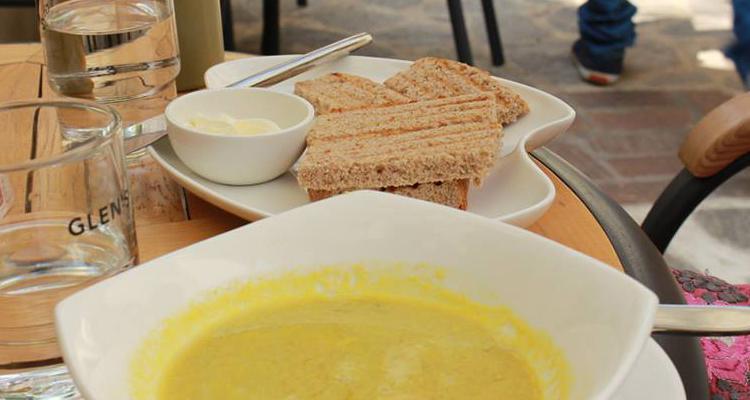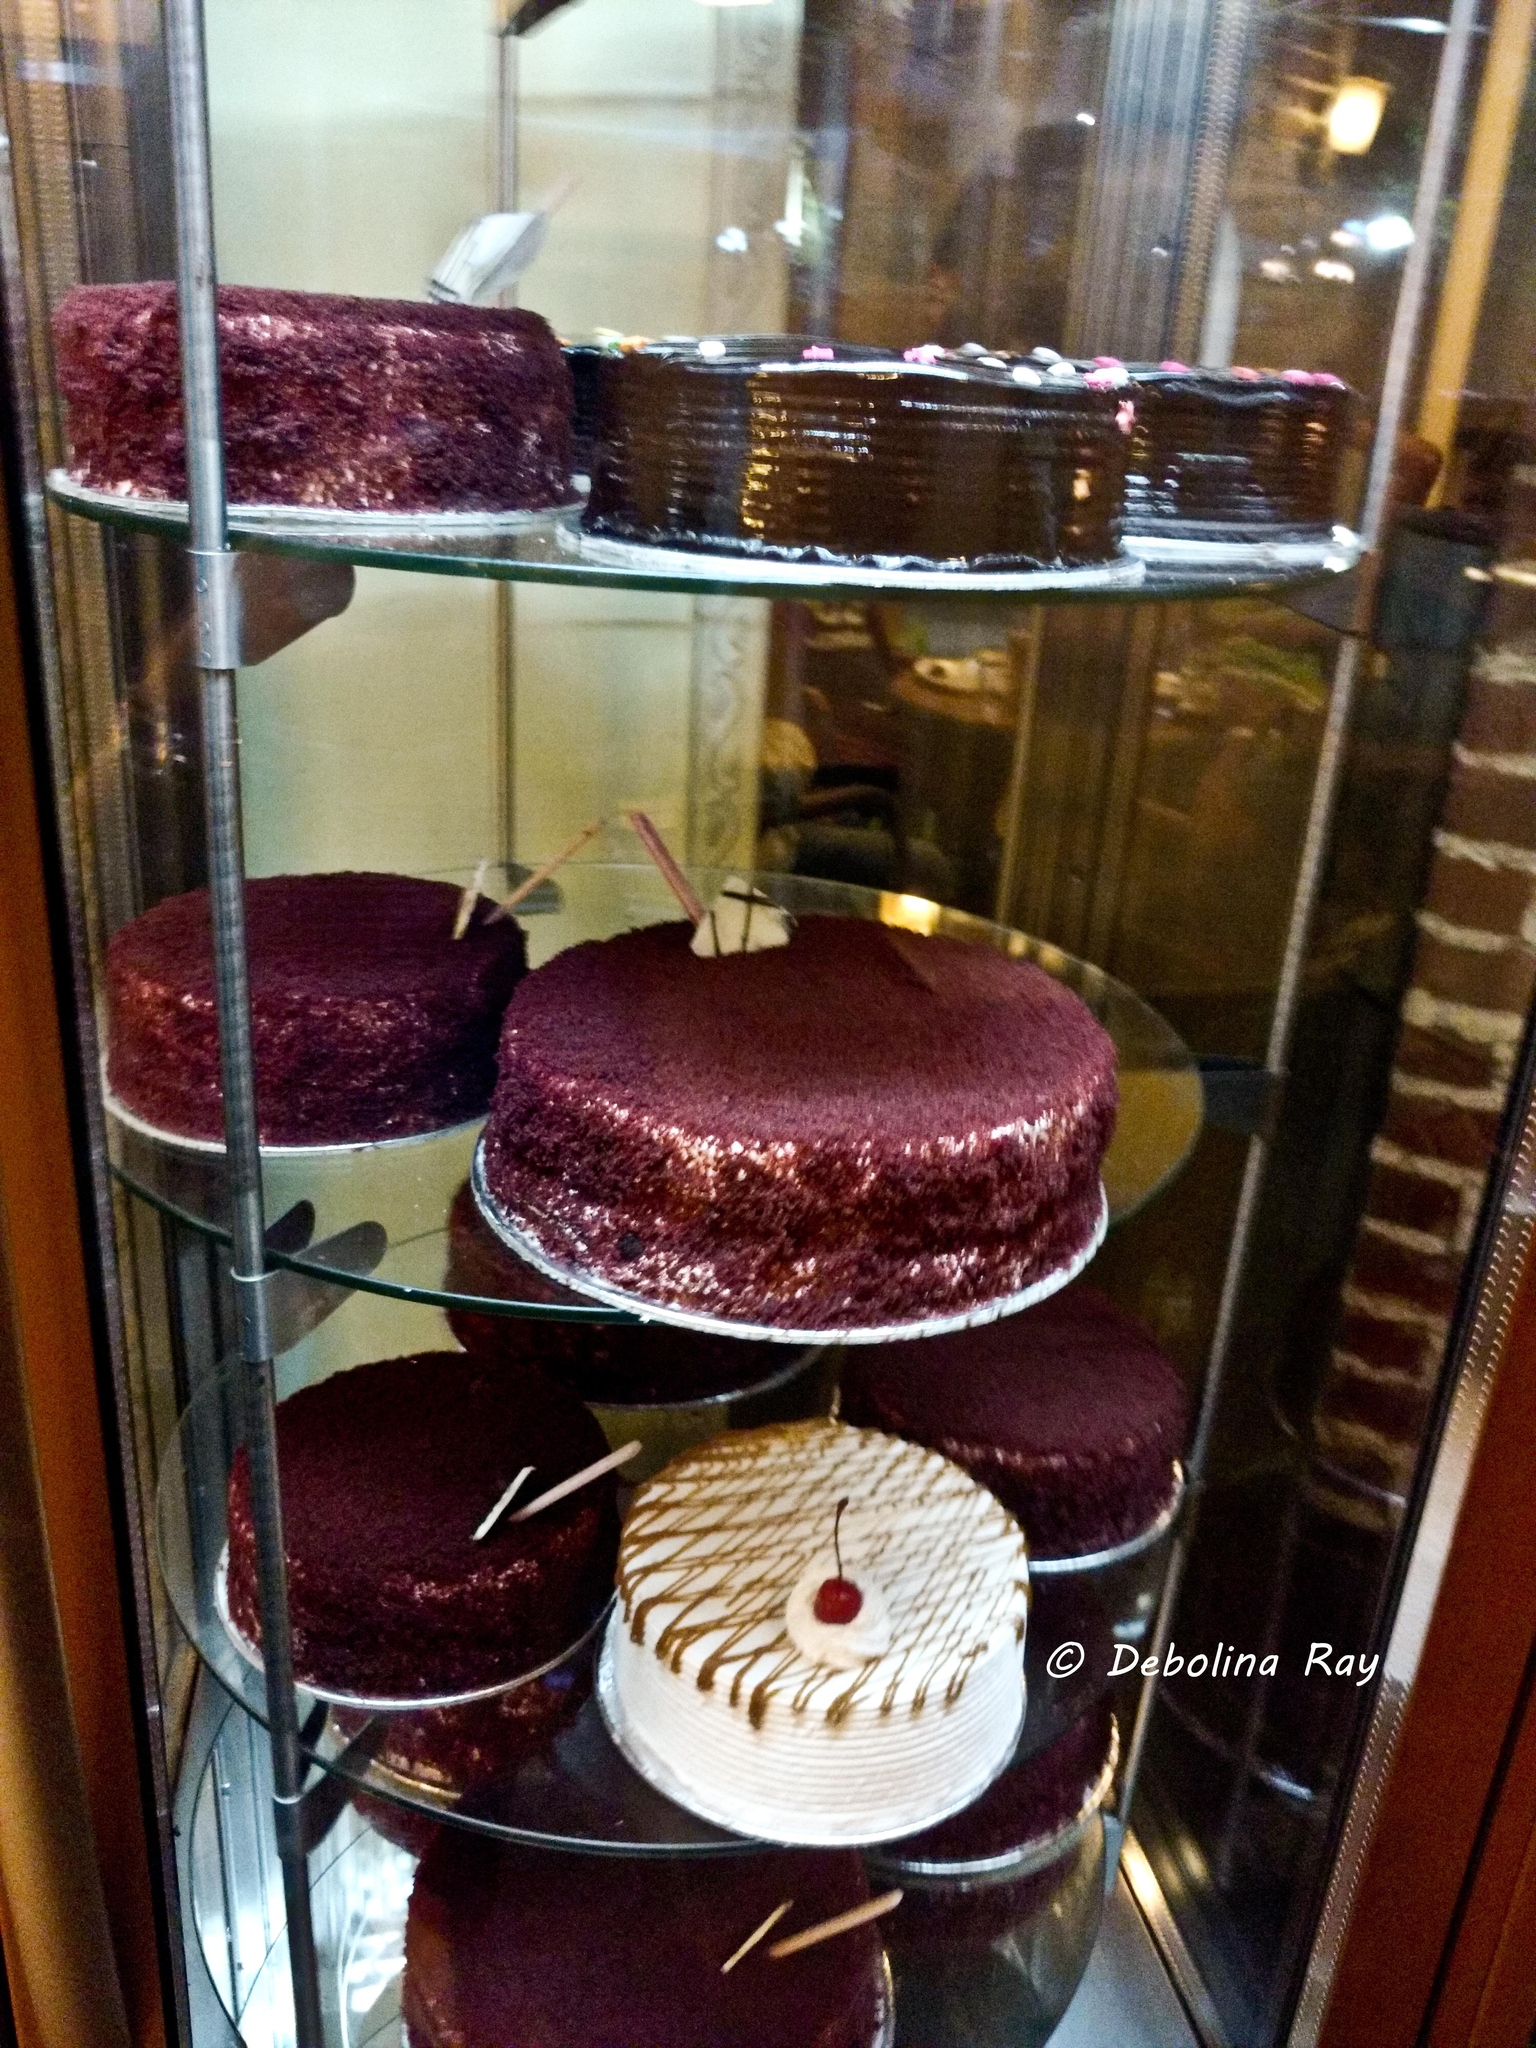The first image is the image on the left, the second image is the image on the right. Assess this claim about the two images: "The right image shows round frosted cake-type desserts displayed on round glass shelves in a tall glass-fronted case.". Correct or not? Answer yes or no. Yes. The first image is the image on the left, the second image is the image on the right. Given the left and right images, does the statement "The right image contains at least one table with napkins on it." hold true? Answer yes or no. No. 